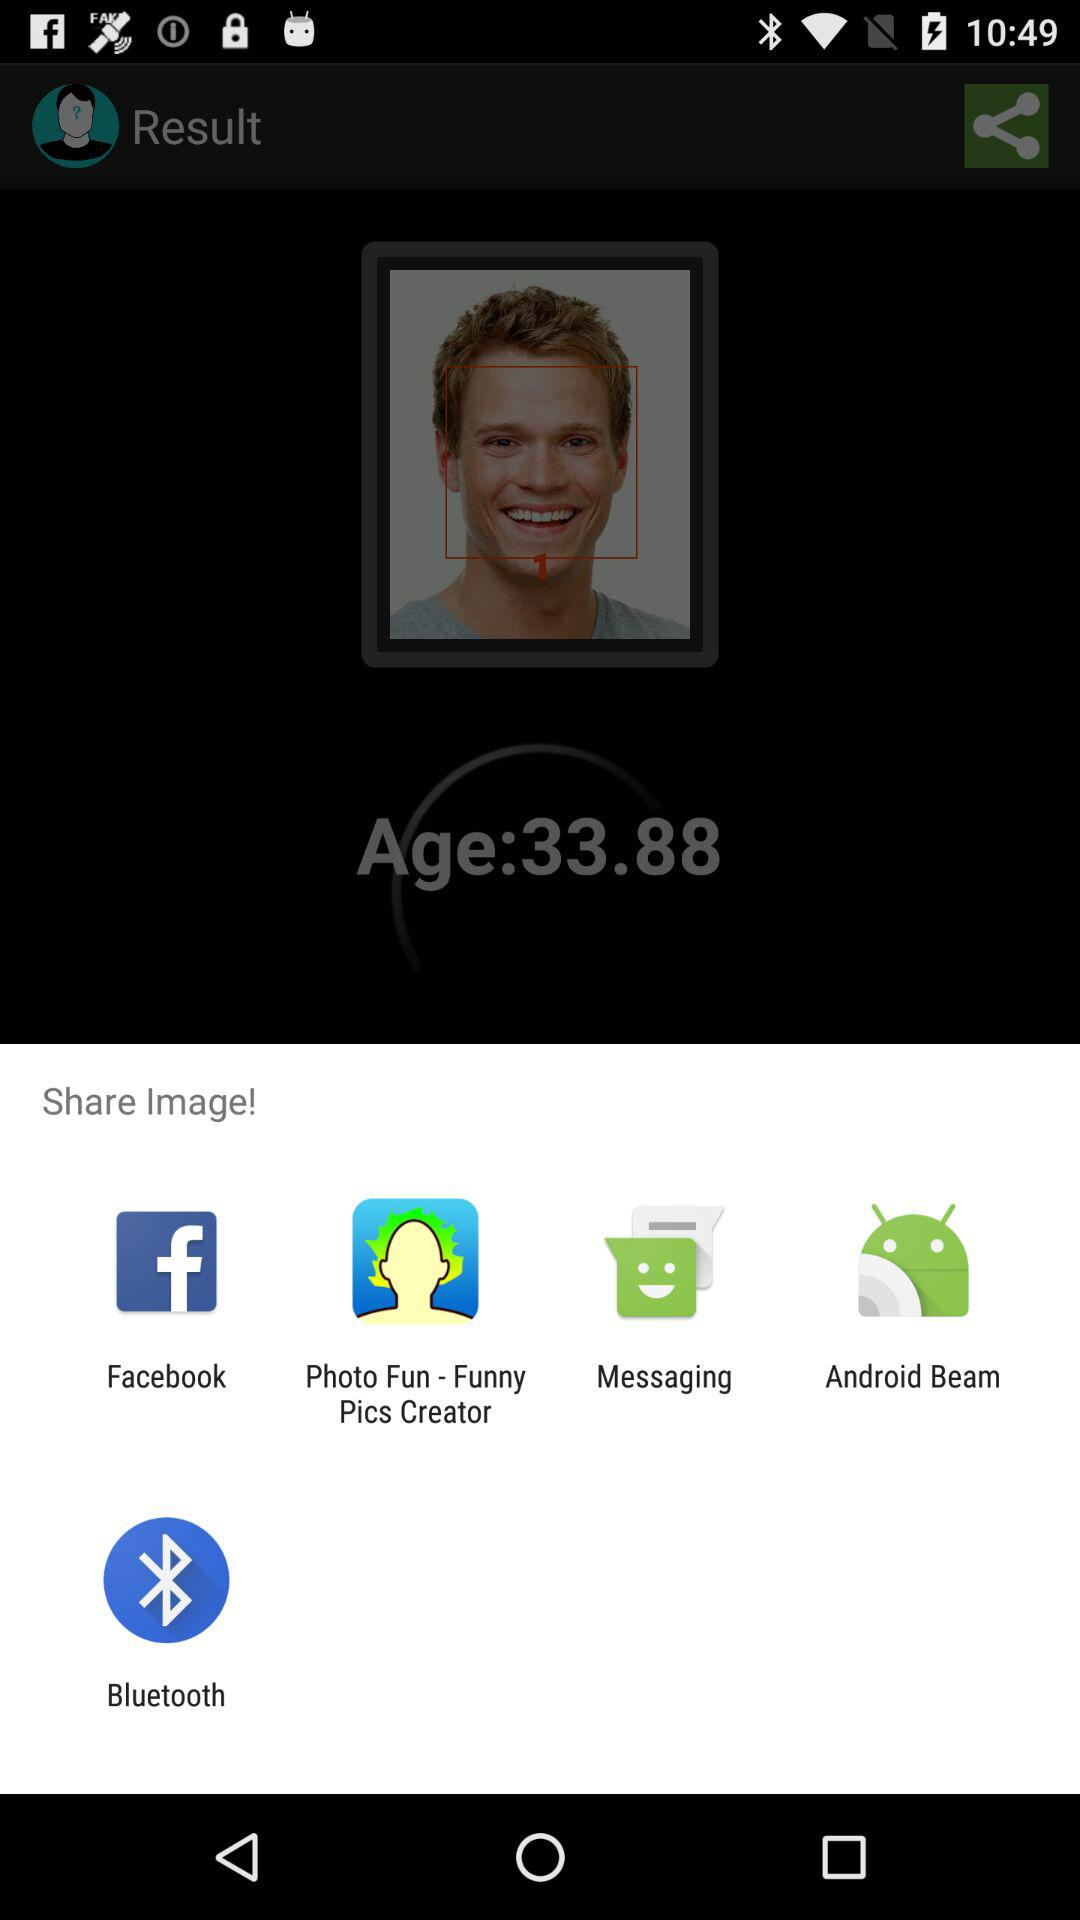Which are the different sharing options? The different sharing options are "Facebook", "Photo Fun - Funny Pics Creator", "Messaging", "Android Beam" and "Bluetooth". 